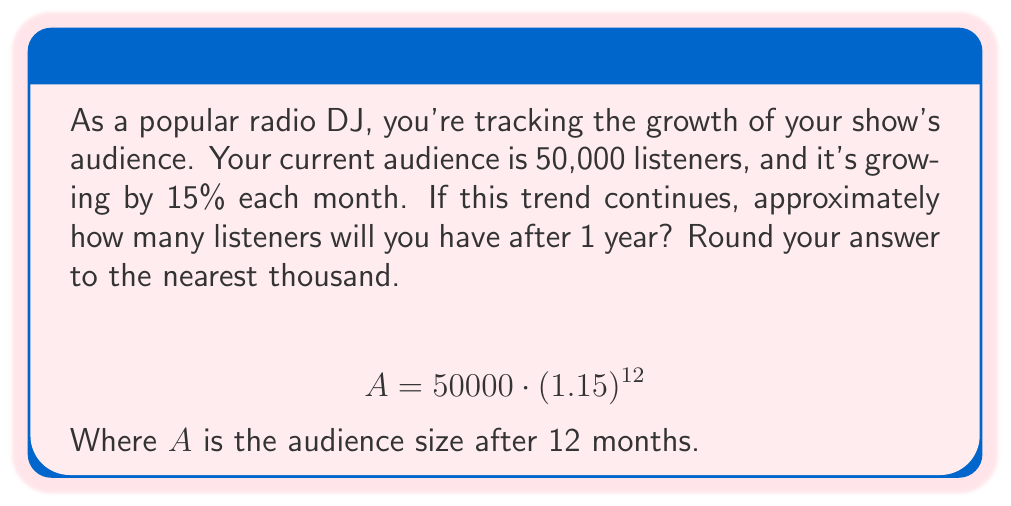Help me with this question. To solve this problem, we'll use the exponential growth formula:

$$A = P \cdot (1 + r)^t$$

Where:
$A$ = final amount
$P$ = initial principal (starting amount)
$r$ = growth rate (as a decimal)
$t$ = time periods

Given:
$P = 50,000$ (initial audience)
$r = 0.15$ (15% growth rate)
$t = 12$ (12 months)

Let's substitute these values into our formula:

$$A = 50000 \cdot (1 + 0.15)^{12}$$
$$A = 50000 \cdot (1.15)^{12}$$

Now, let's calculate:

1) First, compute $(1.15)^{12}$:
   $(1.15)^{12} \approx 5.3505$

2) Multiply this by the initial audience:
   $50000 \cdot 5.3505 = 267,525$

3) Rounding to the nearest thousand:
   $267,525 \approx 268,000$

Therefore, after 1 year (12 months), the audience will grow to approximately 268,000 listeners.
Answer: 268,000 listeners 